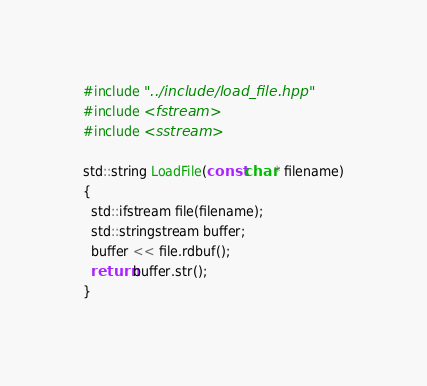Convert code to text. <code><loc_0><loc_0><loc_500><loc_500><_C++_>#include "../include/load_file.hpp"
#include <fstream>
#include <sstream>

std::string LoadFile(const char* filename)
{
  std::ifstream file(filename);
  std::stringstream buffer;
  buffer << file.rdbuf();
  return buffer.str();
}
</code> 